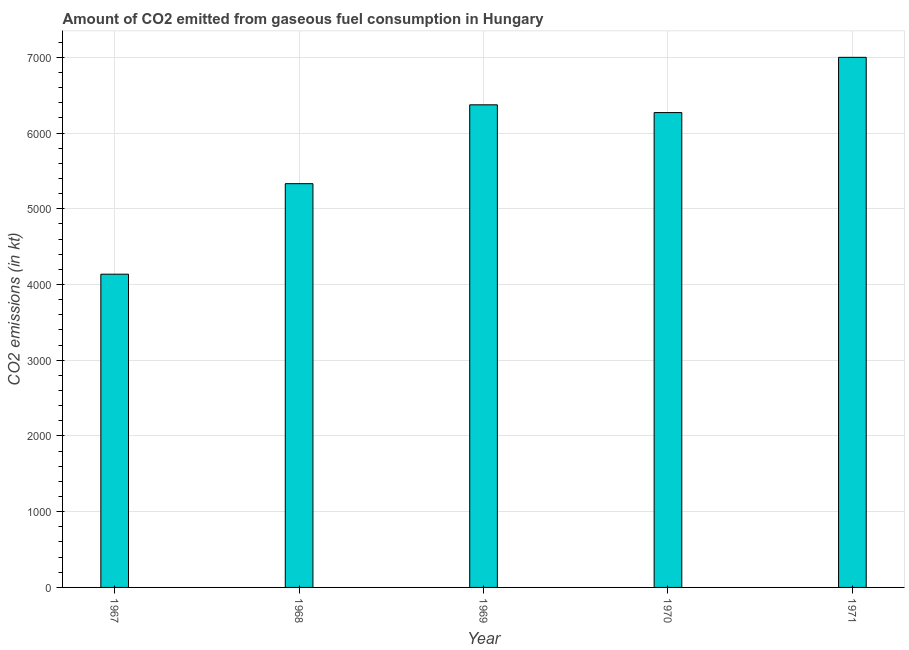Does the graph contain any zero values?
Your answer should be compact. No. What is the title of the graph?
Make the answer very short. Amount of CO2 emitted from gaseous fuel consumption in Hungary. What is the label or title of the Y-axis?
Offer a terse response. CO2 emissions (in kt). What is the co2 emissions from gaseous fuel consumption in 1967?
Your response must be concise. 4136.38. Across all years, what is the maximum co2 emissions from gaseous fuel consumption?
Ensure brevity in your answer.  7000.3. Across all years, what is the minimum co2 emissions from gaseous fuel consumption?
Offer a very short reply. 4136.38. In which year was the co2 emissions from gaseous fuel consumption minimum?
Ensure brevity in your answer.  1967. What is the sum of the co2 emissions from gaseous fuel consumption?
Offer a terse response. 2.91e+04. What is the difference between the co2 emissions from gaseous fuel consumption in 1967 and 1969?
Make the answer very short. -2236.87. What is the average co2 emissions from gaseous fuel consumption per year?
Provide a succinct answer. 5822.46. What is the median co2 emissions from gaseous fuel consumption?
Provide a succinct answer. 6270.57. In how many years, is the co2 emissions from gaseous fuel consumption greater than 4000 kt?
Provide a short and direct response. 5. Do a majority of the years between 1967 and 1970 (inclusive) have co2 emissions from gaseous fuel consumption greater than 200 kt?
Your answer should be compact. Yes. What is the ratio of the co2 emissions from gaseous fuel consumption in 1968 to that in 1971?
Give a very brief answer. 0.76. Is the co2 emissions from gaseous fuel consumption in 1967 less than that in 1970?
Provide a short and direct response. Yes. Is the difference between the co2 emissions from gaseous fuel consumption in 1967 and 1968 greater than the difference between any two years?
Provide a short and direct response. No. What is the difference between the highest and the second highest co2 emissions from gaseous fuel consumption?
Ensure brevity in your answer.  627.06. Is the sum of the co2 emissions from gaseous fuel consumption in 1967 and 1970 greater than the maximum co2 emissions from gaseous fuel consumption across all years?
Provide a succinct answer. Yes. What is the difference between the highest and the lowest co2 emissions from gaseous fuel consumption?
Keep it short and to the point. 2863.93. How many bars are there?
Your answer should be compact. 5. Are all the bars in the graph horizontal?
Keep it short and to the point. No. Are the values on the major ticks of Y-axis written in scientific E-notation?
Your response must be concise. No. What is the CO2 emissions (in kt) in 1967?
Ensure brevity in your answer.  4136.38. What is the CO2 emissions (in kt) of 1968?
Provide a short and direct response. 5331.82. What is the CO2 emissions (in kt) in 1969?
Provide a succinct answer. 6373.25. What is the CO2 emissions (in kt) in 1970?
Make the answer very short. 6270.57. What is the CO2 emissions (in kt) of 1971?
Your answer should be very brief. 7000.3. What is the difference between the CO2 emissions (in kt) in 1967 and 1968?
Your response must be concise. -1195.44. What is the difference between the CO2 emissions (in kt) in 1967 and 1969?
Offer a terse response. -2236.87. What is the difference between the CO2 emissions (in kt) in 1967 and 1970?
Give a very brief answer. -2134.19. What is the difference between the CO2 emissions (in kt) in 1967 and 1971?
Ensure brevity in your answer.  -2863.93. What is the difference between the CO2 emissions (in kt) in 1968 and 1969?
Provide a succinct answer. -1041.43. What is the difference between the CO2 emissions (in kt) in 1968 and 1970?
Keep it short and to the point. -938.75. What is the difference between the CO2 emissions (in kt) in 1968 and 1971?
Provide a short and direct response. -1668.48. What is the difference between the CO2 emissions (in kt) in 1969 and 1970?
Your response must be concise. 102.68. What is the difference between the CO2 emissions (in kt) in 1969 and 1971?
Provide a succinct answer. -627.06. What is the difference between the CO2 emissions (in kt) in 1970 and 1971?
Provide a succinct answer. -729.73. What is the ratio of the CO2 emissions (in kt) in 1967 to that in 1968?
Provide a succinct answer. 0.78. What is the ratio of the CO2 emissions (in kt) in 1967 to that in 1969?
Your response must be concise. 0.65. What is the ratio of the CO2 emissions (in kt) in 1967 to that in 1970?
Your answer should be compact. 0.66. What is the ratio of the CO2 emissions (in kt) in 1967 to that in 1971?
Provide a succinct answer. 0.59. What is the ratio of the CO2 emissions (in kt) in 1968 to that in 1969?
Provide a short and direct response. 0.84. What is the ratio of the CO2 emissions (in kt) in 1968 to that in 1971?
Give a very brief answer. 0.76. What is the ratio of the CO2 emissions (in kt) in 1969 to that in 1971?
Make the answer very short. 0.91. What is the ratio of the CO2 emissions (in kt) in 1970 to that in 1971?
Your response must be concise. 0.9. 